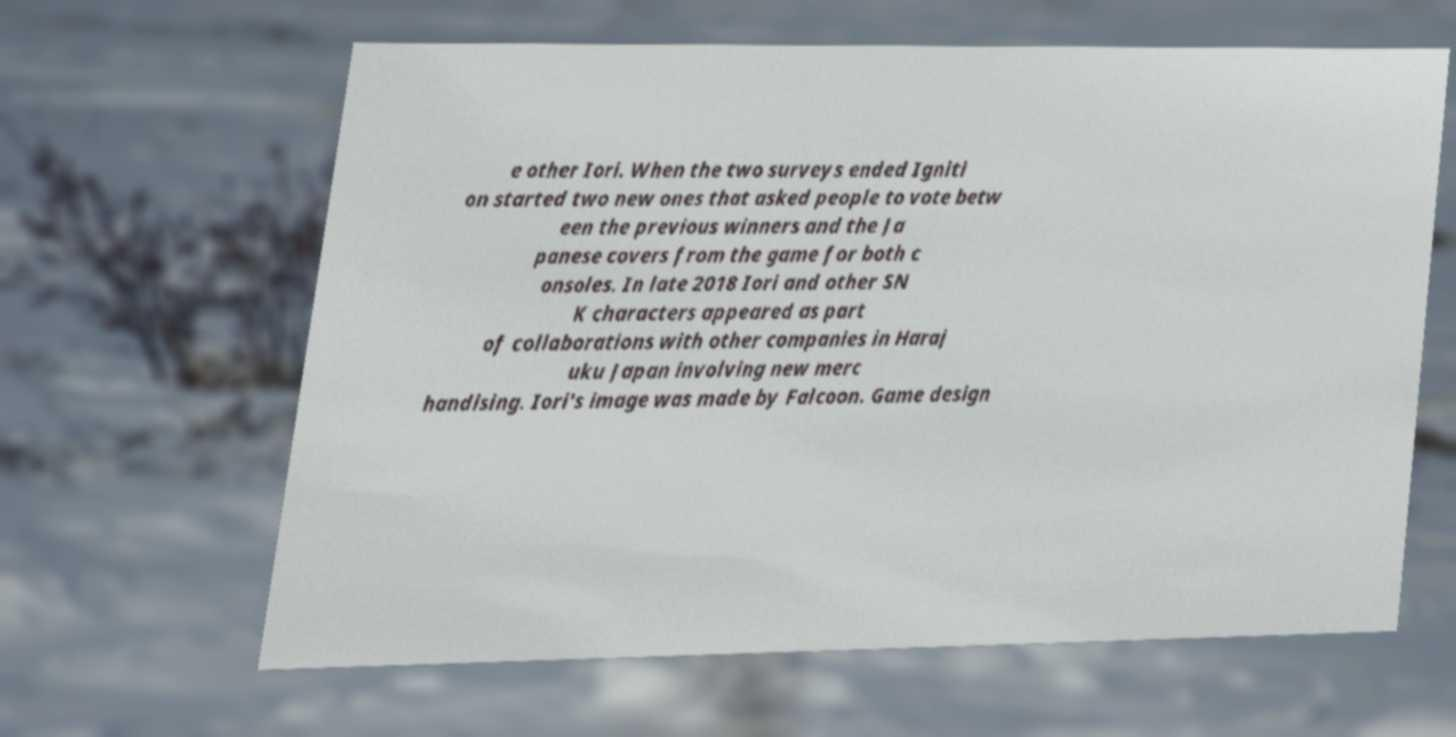Please identify and transcribe the text found in this image. e other Iori. When the two surveys ended Igniti on started two new ones that asked people to vote betw een the previous winners and the Ja panese covers from the game for both c onsoles. In late 2018 Iori and other SN K characters appeared as part of collaborations with other companies in Haraj uku Japan involving new merc handising. Iori's image was made by Falcoon. Game design 